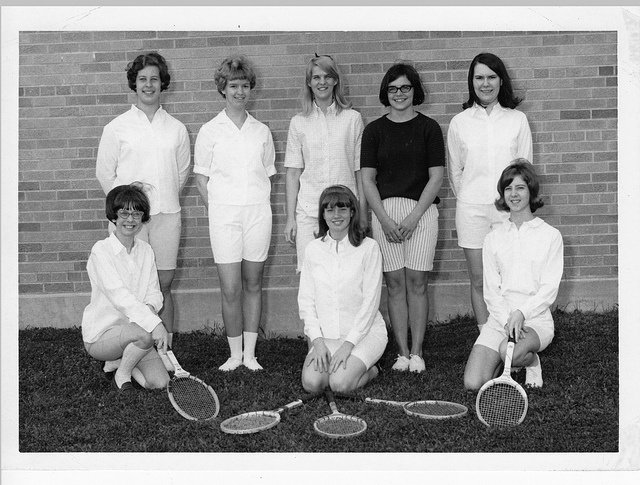Describe the objects in this image and their specific colors. I can see people in lightgray, black, gray, and darkgray tones, people in lightgray, gray, darkgray, and black tones, people in lightgray, darkgray, gray, and black tones, people in lightgray, darkgray, gray, and black tones, and people in lightgray, gainsboro, darkgray, black, and gray tones in this image. 